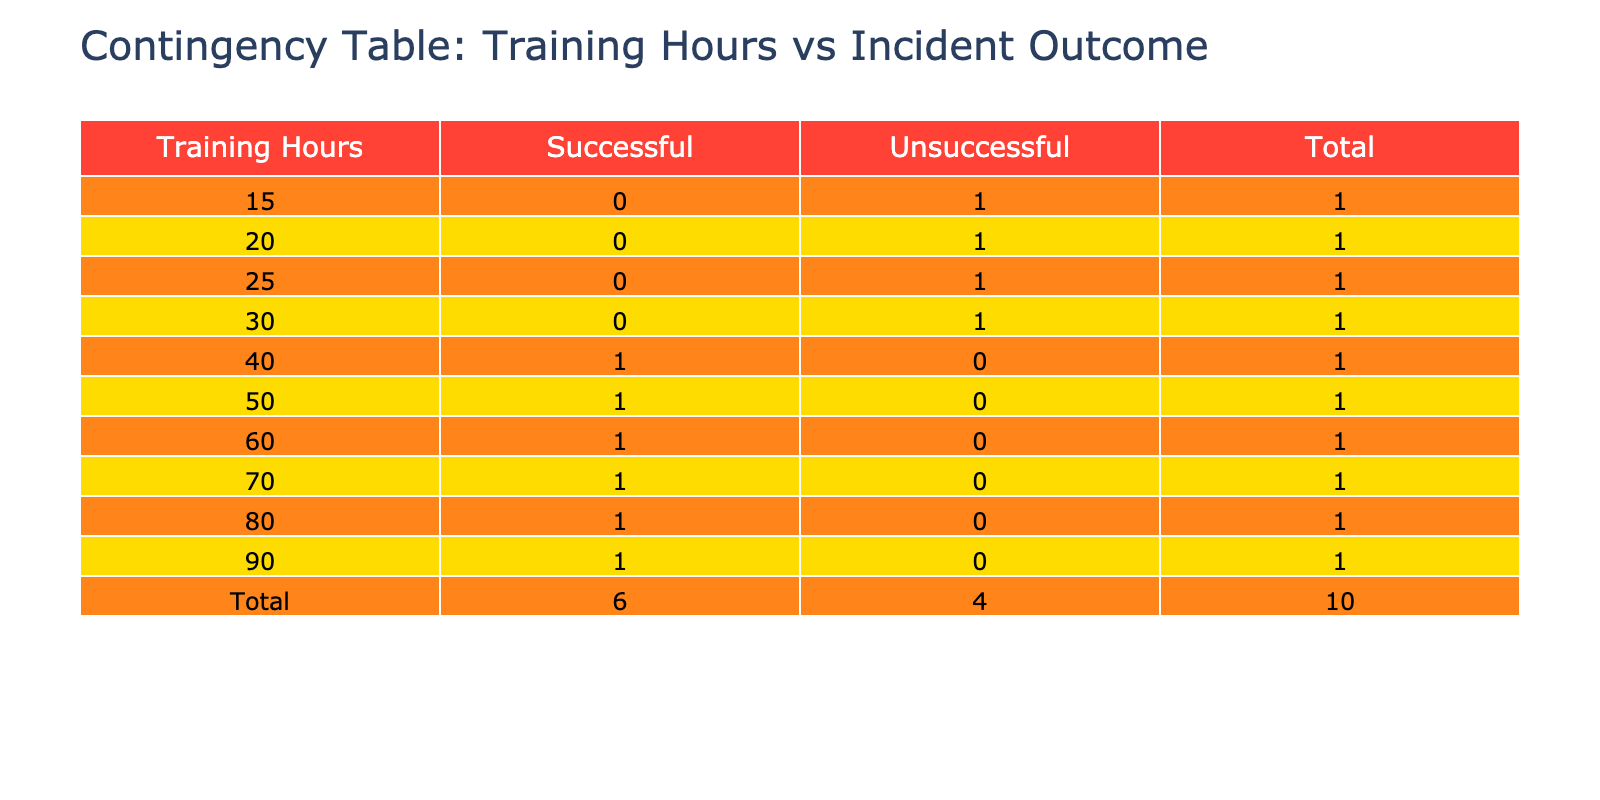What is the total number of successful incidents? To find the total number of successful incidents, I will look at the 'Successful' column and count the number of hours that fall under this category. The successful incidents are at 40, 60, 50, 80, and 90 hours. Counting these gives us a total of 5 successful incidents.
Answer: 5 What training hour was associated with the least number of successful outcomes? I will look at the 'Successful' column in relation to the training hours. The only training hour associated with an unsuccessful outcome is at 30, 20, 15, and 25 hours. Out of these, the minimum is 15 hours, meaning 15 hours had the least training hours and did not achieve a successful incident.
Answer: 15 What is the average number of training hours for successful incidents? To calculate the average, I sum the successful training hours: 40 + 60 + 50 + 80 + 90 = 320. Then I divide this sum by the number of successful incidents, which is 5. So, 320 divided by 5 equals 64.
Answer: 64 Is there any training hour with a 100% success rate? I will verify if any training hour has all outcomes marked as successful. Looking at the training hours, I see multiple hours report 'Successful', but there are hours (15, 20, 25, and 30) which had unsuccessful outcomes. Thus, not a single training hour has a 100% success rate.
Answer: No What is the difference in the total number of successful and unsuccessful incidents? First, I will count the total successful incidents, which is 5, and the total unsuccessful incidents, which is 4. The difference is calculated as 5 (successful) - 4 (unsuccessful) = 1. So the difference in total incidents is 1.
Answer: 1 What is the count of incidents for training hours greater than 50? For this, I will examine the training hours greater than 50, which are 60, 80, and 90. There are 5 incidents associated with these hours: 60 (successful), 80 (successful), and 90 (successful). Thus, the total count is 3.
Answer: 3 How many unsuccessful incidents are associated with less than 30 training hours? The training hours associated with unsuccessful incidents include 20, 15, and 25. Since all of these (3 incidents) are less than 30, the total count is 3 unsuccessful incidents.
Answer: 3 What is the modal number of training hours for successful incidents? The training hours for successful incidents are 40, 60, 50, 80, and 90. The values don't repeat, and since each hour is unique, there is no mode present, which is defined as the most frequent number of occurrences.
Answer: None 